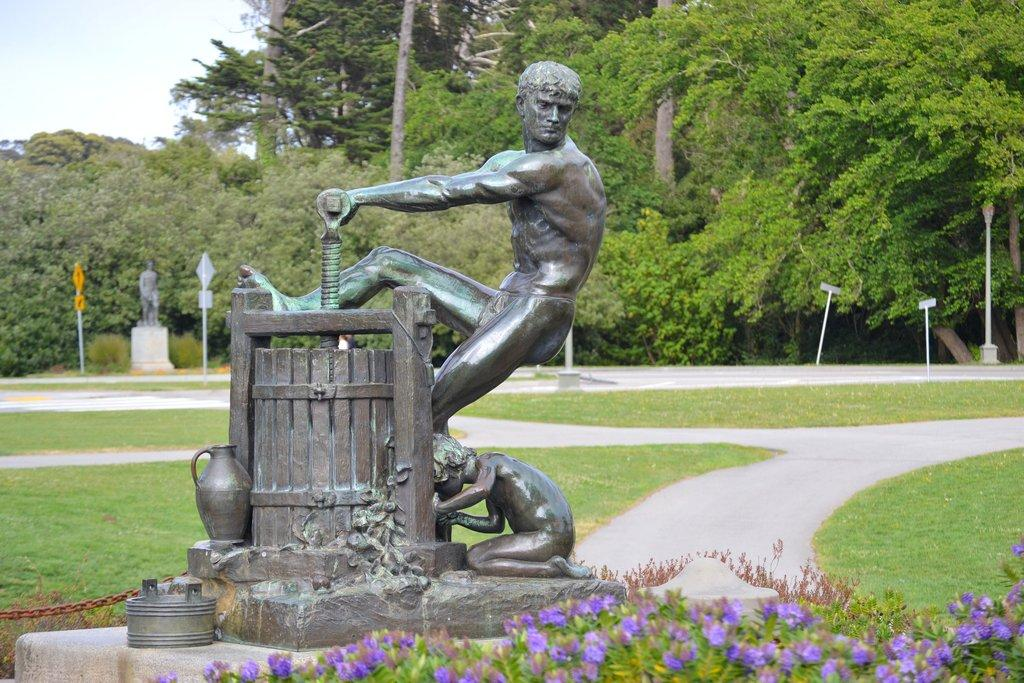What is the main subject in the image? There is a statue in the image. What can be seen at the bottom of the image? There are plants at the bottom of the image. What is visible in the background of the image? There are poles and trees in the background of the image. What arithmetic problem is the statue trying to solve in the image? The statue is not solving any arithmetic problem in the image; it is a stationary object. 